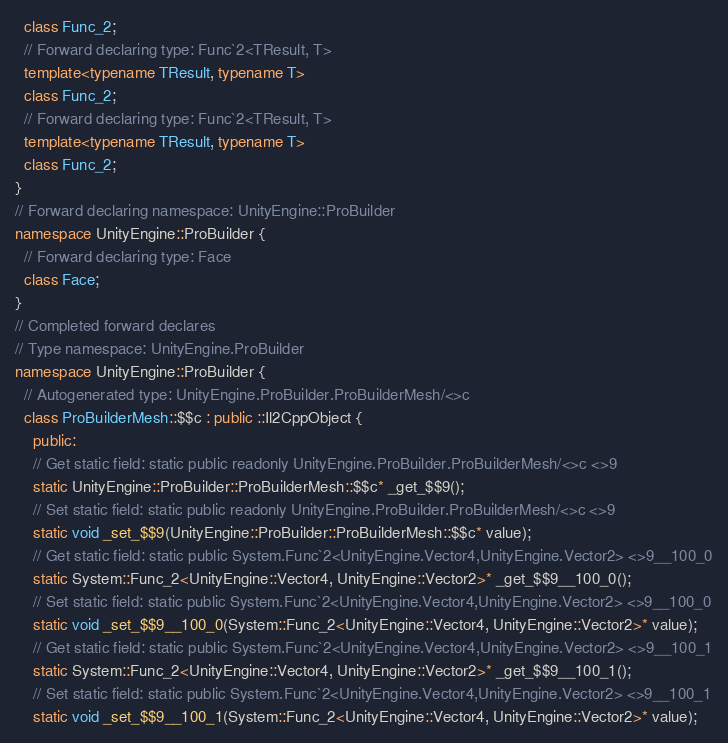<code> <loc_0><loc_0><loc_500><loc_500><_C++_>  class Func_2;
  // Forward declaring type: Func`2<TResult, T>
  template<typename TResult, typename T>
  class Func_2;
  // Forward declaring type: Func`2<TResult, T>
  template<typename TResult, typename T>
  class Func_2;
}
// Forward declaring namespace: UnityEngine::ProBuilder
namespace UnityEngine::ProBuilder {
  // Forward declaring type: Face
  class Face;
}
// Completed forward declares
// Type namespace: UnityEngine.ProBuilder
namespace UnityEngine::ProBuilder {
  // Autogenerated type: UnityEngine.ProBuilder.ProBuilderMesh/<>c
  class ProBuilderMesh::$$c : public ::Il2CppObject {
    public:
    // Get static field: static public readonly UnityEngine.ProBuilder.ProBuilderMesh/<>c <>9
    static UnityEngine::ProBuilder::ProBuilderMesh::$$c* _get_$$9();
    // Set static field: static public readonly UnityEngine.ProBuilder.ProBuilderMesh/<>c <>9
    static void _set_$$9(UnityEngine::ProBuilder::ProBuilderMesh::$$c* value);
    // Get static field: static public System.Func`2<UnityEngine.Vector4,UnityEngine.Vector2> <>9__100_0
    static System::Func_2<UnityEngine::Vector4, UnityEngine::Vector2>* _get_$$9__100_0();
    // Set static field: static public System.Func`2<UnityEngine.Vector4,UnityEngine.Vector2> <>9__100_0
    static void _set_$$9__100_0(System::Func_2<UnityEngine::Vector4, UnityEngine::Vector2>* value);
    // Get static field: static public System.Func`2<UnityEngine.Vector4,UnityEngine.Vector2> <>9__100_1
    static System::Func_2<UnityEngine::Vector4, UnityEngine::Vector2>* _get_$$9__100_1();
    // Set static field: static public System.Func`2<UnityEngine.Vector4,UnityEngine.Vector2> <>9__100_1
    static void _set_$$9__100_1(System::Func_2<UnityEngine::Vector4, UnityEngine::Vector2>* value);</code> 